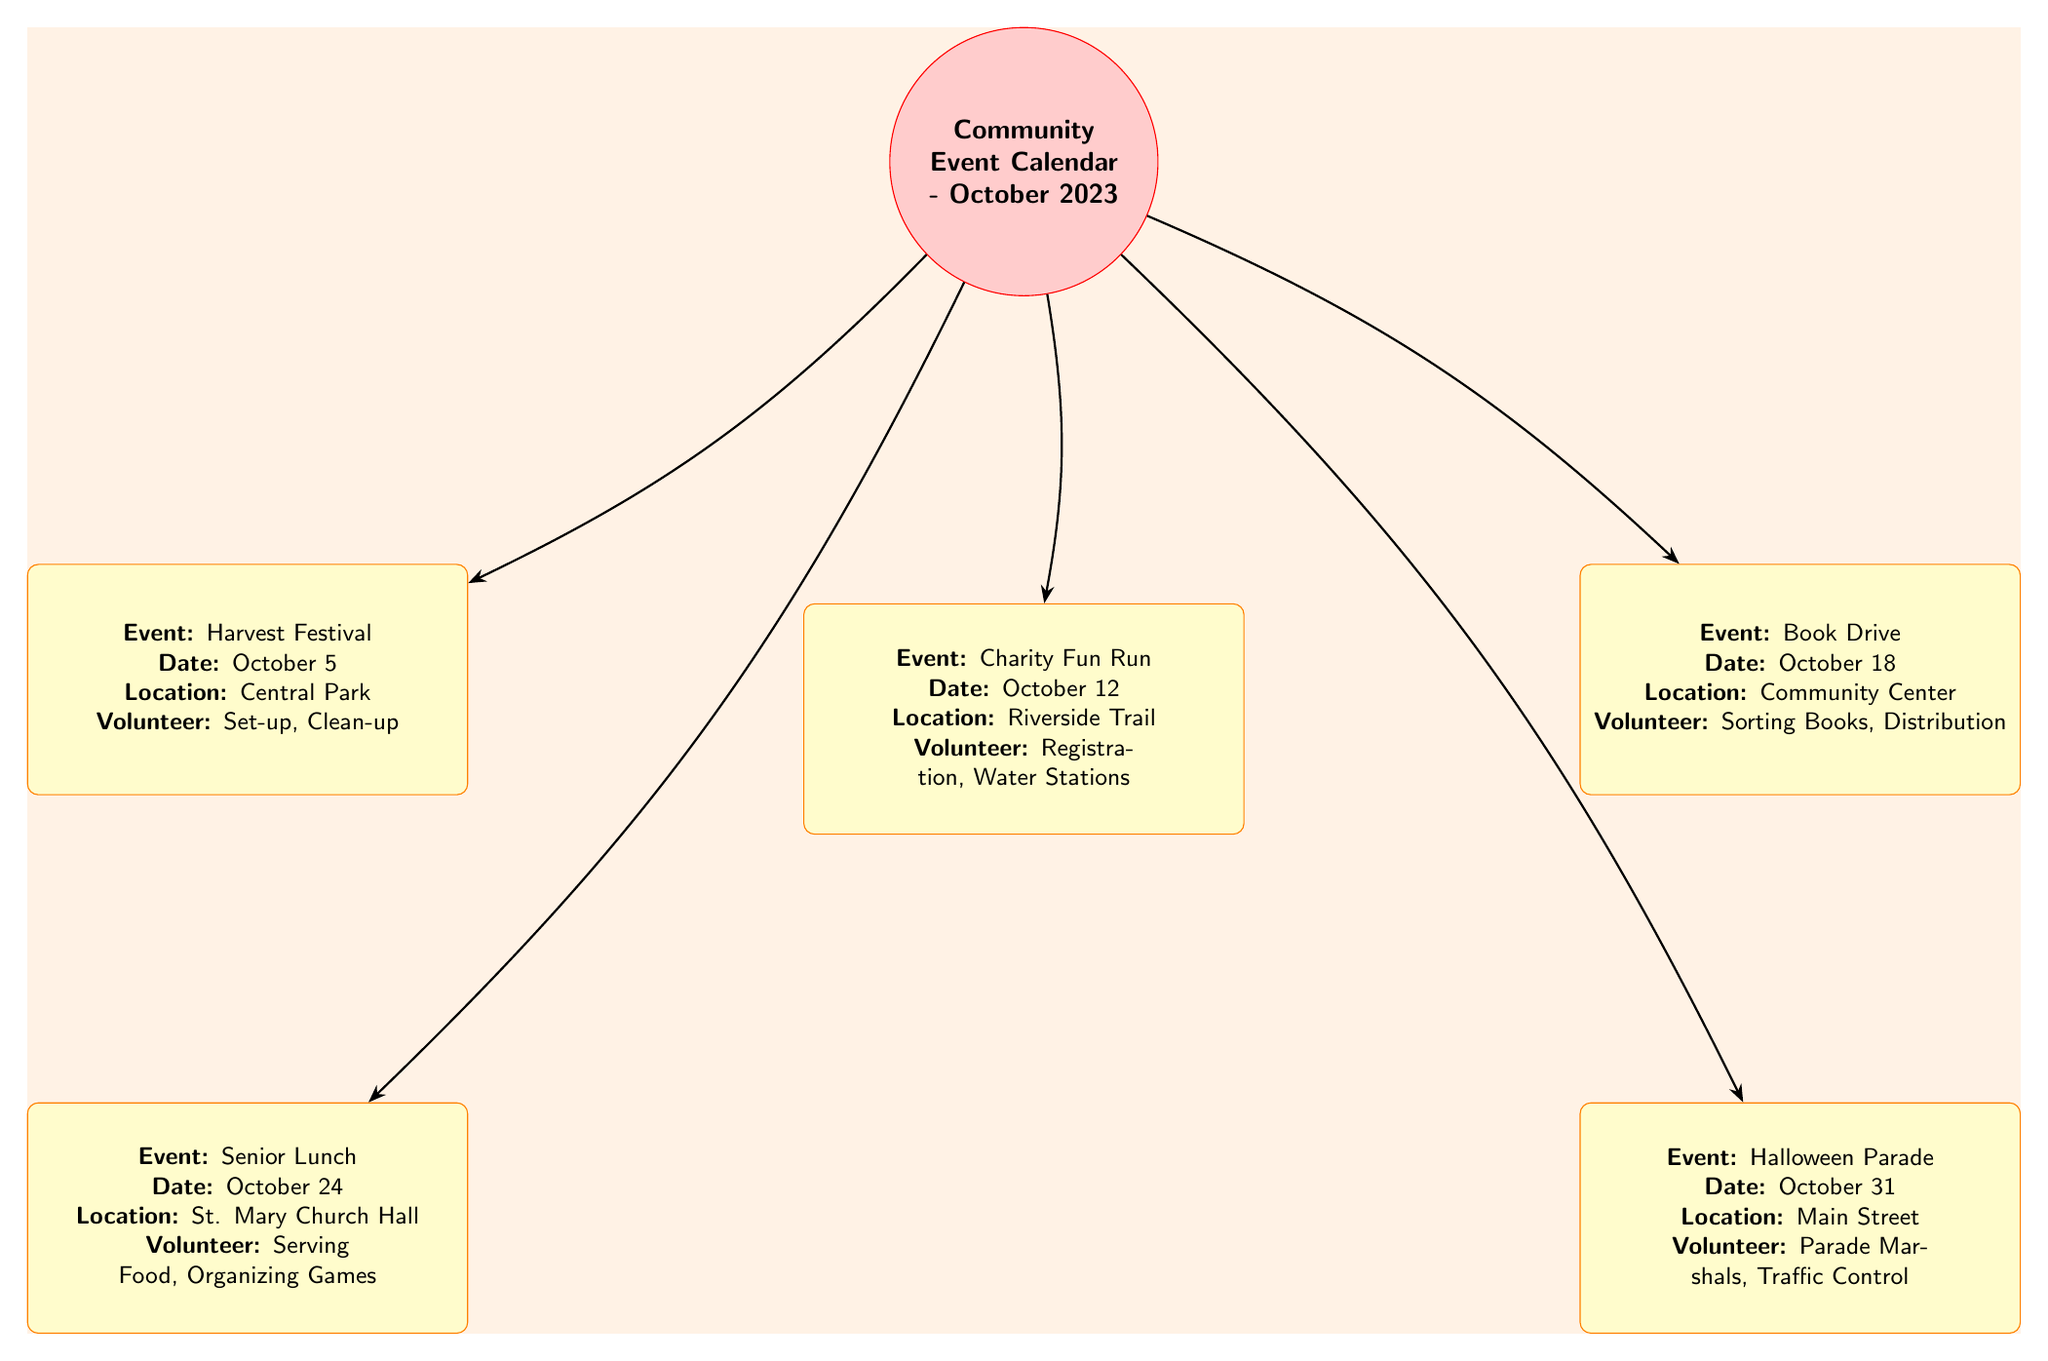What is the date of the Harvest Festival? The diagram lists the Harvest Festival under the event node, detailing the date as October 5.
Answer: October 5 How many events are listed in the calendar? By counting the event nodes in the diagram, there are five events: Harvest Festival, Charity Fun Run, Book Drive, Senior Lunch, and Halloween Parade.
Answer: Five What is the location of the Charity Fun Run? The diagram specifies that the Charity Fun Run is taking place at Riverside Trail.
Answer: Riverside Trail Which event requires volunteers for serving food? The Senior Lunch event notes that volunteers are needed for serving food as detailed in its node.
Answer: Senior Lunch What are the volunteer opportunities for the Book Drive? The diagram indicates the volunteer tasks for the Book Drive as sorting books and distribution, requiring multiple actions from participants.
Answer: Sorting Books, Distribution What is the last event scheduled for October 2023? By looking at the order of the events, the last event listed is the Halloween Parade, which occurs on October 31.
Answer: Halloween Parade Which event takes place at Central Park? The diagram points out that the Harvest Festival is specifically located at Central Park, as noted within its event details.
Answer: Harvest Festival What types of volunteer roles are needed for the Halloween Parade? The information in the diagram describes the volunteer roles for the Halloween Parade as parade marshals and traffic control.
Answer: Parade Marshals, Traffic Control What is the primary color used for the event nodes? By examining the design of the diagram, the event nodes are filled with yellow!20, which gives them a light yellow appearance.
Answer: Yellow 